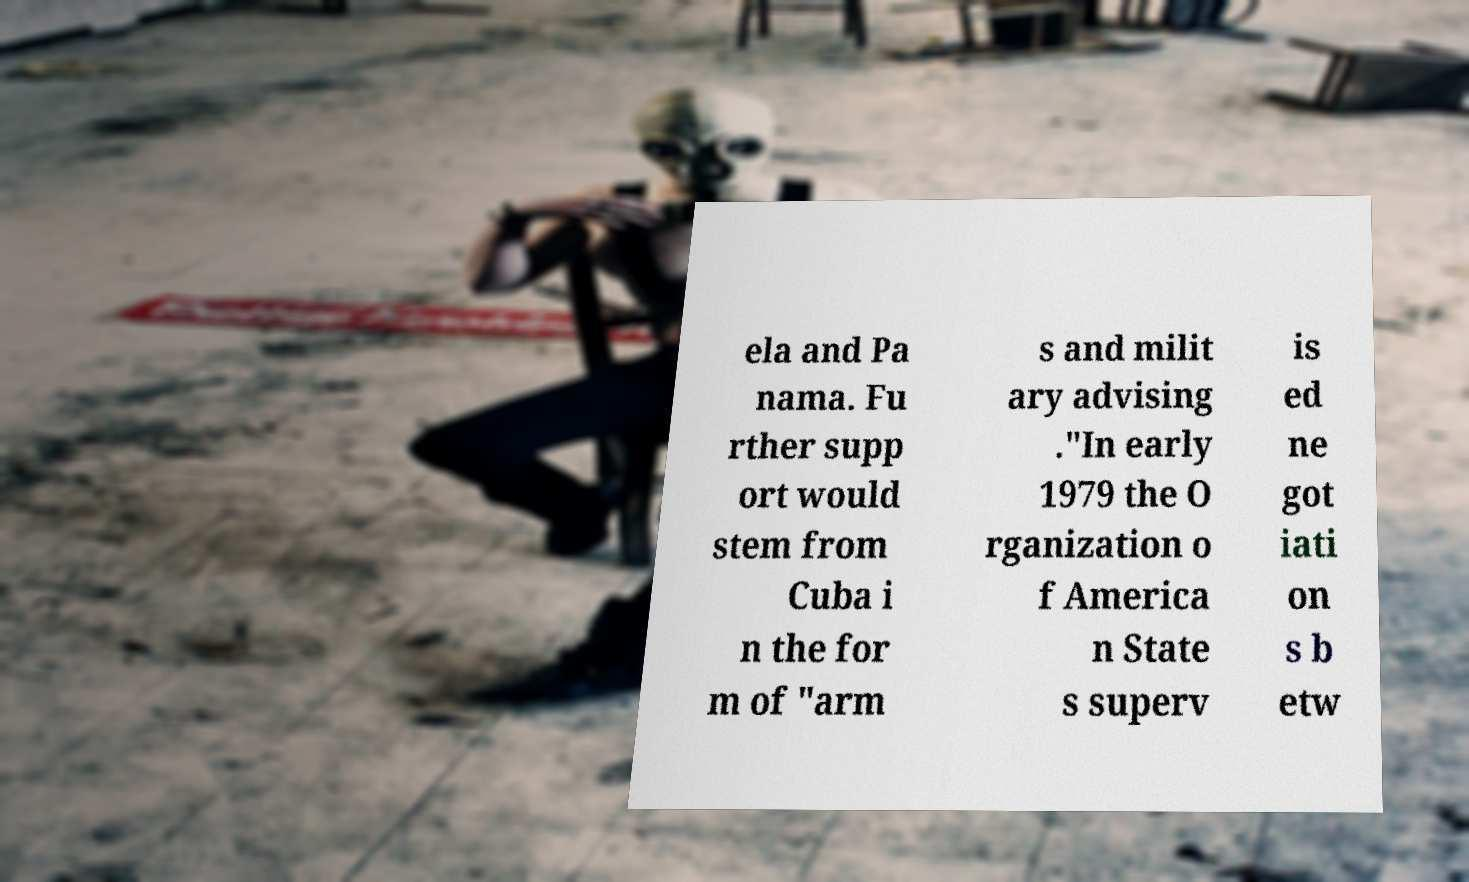Please read and relay the text visible in this image. What does it say? ela and Pa nama. Fu rther supp ort would stem from Cuba i n the for m of "arm s and milit ary advising ."In early 1979 the O rganization o f America n State s superv is ed ne got iati on s b etw 